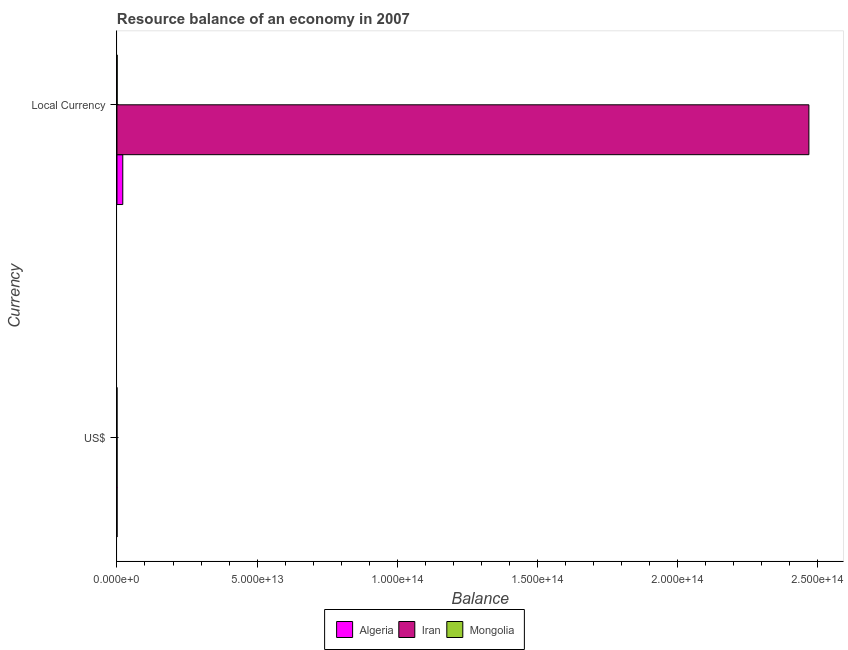How many bars are there on the 1st tick from the bottom?
Your answer should be very brief. 3. What is the label of the 1st group of bars from the top?
Your answer should be compact. Local Currency. What is the resource balance in constant us$ in Iran?
Make the answer very short. 2.47e+14. Across all countries, what is the maximum resource balance in constant us$?
Offer a terse response. 2.47e+14. Across all countries, what is the minimum resource balance in us$?
Your answer should be compact. 5.71e+07. In which country was the resource balance in constant us$ maximum?
Offer a very short reply. Iran. In which country was the resource balance in us$ minimum?
Offer a terse response. Mongolia. What is the total resource balance in us$ in the graph?
Make the answer very short. 5.66e+1. What is the difference between the resource balance in constant us$ in Mongolia and that in Algeria?
Give a very brief answer. -2.01e+12. What is the difference between the resource balance in us$ in Iran and the resource balance in constant us$ in Mongolia?
Provide a short and direct response. -4.02e+1. What is the average resource balance in constant us$ per country?
Make the answer very short. 8.30e+13. What is the difference between the resource balance in constant us$ and resource balance in us$ in Mongolia?
Your answer should be very brief. 6.68e+1. What is the ratio of the resource balance in constant us$ in Iran to that in Mongolia?
Offer a terse response. 3693.65. In how many countries, is the resource balance in constant us$ greater than the average resource balance in constant us$ taken over all countries?
Offer a terse response. 1. What does the 1st bar from the top in US$ represents?
Your answer should be very brief. Mongolia. What does the 3rd bar from the bottom in Local Currency represents?
Your response must be concise. Mongolia. How many bars are there?
Your answer should be very brief. 6. What is the difference between two consecutive major ticks on the X-axis?
Provide a short and direct response. 5.00e+13. Are the values on the major ticks of X-axis written in scientific E-notation?
Make the answer very short. Yes. Does the graph contain any zero values?
Give a very brief answer. No. Where does the legend appear in the graph?
Give a very brief answer. Bottom center. How many legend labels are there?
Provide a short and direct response. 3. What is the title of the graph?
Provide a succinct answer. Resource balance of an economy in 2007. Does "Malta" appear as one of the legend labels in the graph?
Your answer should be compact. No. What is the label or title of the X-axis?
Offer a terse response. Balance. What is the label or title of the Y-axis?
Ensure brevity in your answer.  Currency. What is the Balance in Algeria in US$?
Keep it short and to the point. 3.00e+1. What is the Balance of Iran in US$?
Provide a short and direct response. 2.66e+1. What is the Balance in Mongolia in US$?
Provide a short and direct response. 5.71e+07. What is the Balance in Algeria in Local Currency?
Provide a short and direct response. 2.08e+12. What is the Balance of Iran in Local Currency?
Provide a succinct answer. 2.47e+14. What is the Balance of Mongolia in Local Currency?
Provide a succinct answer. 6.68e+1. Across all Currency, what is the maximum Balance of Algeria?
Keep it short and to the point. 2.08e+12. Across all Currency, what is the maximum Balance of Iran?
Give a very brief answer. 2.47e+14. Across all Currency, what is the maximum Balance of Mongolia?
Provide a succinct answer. 6.68e+1. Across all Currency, what is the minimum Balance of Algeria?
Ensure brevity in your answer.  3.00e+1. Across all Currency, what is the minimum Balance of Iran?
Provide a short and direct response. 2.66e+1. Across all Currency, what is the minimum Balance in Mongolia?
Offer a terse response. 5.71e+07. What is the total Balance in Algeria in the graph?
Provide a succinct answer. 2.11e+12. What is the total Balance in Iran in the graph?
Your answer should be compact. 2.47e+14. What is the total Balance in Mongolia in the graph?
Offer a very short reply. 6.69e+1. What is the difference between the Balance of Algeria in US$ and that in Local Currency?
Provide a succinct answer. -2.05e+12. What is the difference between the Balance in Iran in US$ and that in Local Currency?
Your response must be concise. -2.47e+14. What is the difference between the Balance in Mongolia in US$ and that in Local Currency?
Your answer should be compact. -6.68e+1. What is the difference between the Balance in Algeria in US$ and the Balance in Iran in Local Currency?
Provide a succinct answer. -2.47e+14. What is the difference between the Balance of Algeria in US$ and the Balance of Mongolia in Local Currency?
Provide a short and direct response. -3.69e+1. What is the difference between the Balance of Iran in US$ and the Balance of Mongolia in Local Currency?
Provide a succinct answer. -4.02e+1. What is the average Balance in Algeria per Currency?
Your answer should be very brief. 1.05e+12. What is the average Balance in Iran per Currency?
Your answer should be compact. 1.23e+14. What is the average Balance of Mongolia per Currency?
Keep it short and to the point. 3.34e+1. What is the difference between the Balance in Algeria and Balance in Iran in US$?
Provide a short and direct response. 3.36e+09. What is the difference between the Balance of Algeria and Balance of Mongolia in US$?
Your answer should be very brief. 2.99e+1. What is the difference between the Balance of Iran and Balance of Mongolia in US$?
Keep it short and to the point. 2.65e+1. What is the difference between the Balance in Algeria and Balance in Iran in Local Currency?
Offer a very short reply. -2.45e+14. What is the difference between the Balance in Algeria and Balance in Mongolia in Local Currency?
Your answer should be compact. 2.01e+12. What is the difference between the Balance of Iran and Balance of Mongolia in Local Currency?
Provide a succinct answer. 2.47e+14. What is the ratio of the Balance in Algeria in US$ to that in Local Currency?
Provide a short and direct response. 0.01. What is the ratio of the Balance of Iran in US$ to that in Local Currency?
Your response must be concise. 0. What is the ratio of the Balance in Mongolia in US$ to that in Local Currency?
Provide a succinct answer. 0. What is the difference between the highest and the second highest Balance in Algeria?
Make the answer very short. 2.05e+12. What is the difference between the highest and the second highest Balance of Iran?
Your response must be concise. 2.47e+14. What is the difference between the highest and the second highest Balance in Mongolia?
Provide a short and direct response. 6.68e+1. What is the difference between the highest and the lowest Balance of Algeria?
Provide a short and direct response. 2.05e+12. What is the difference between the highest and the lowest Balance of Iran?
Your answer should be compact. 2.47e+14. What is the difference between the highest and the lowest Balance in Mongolia?
Ensure brevity in your answer.  6.68e+1. 